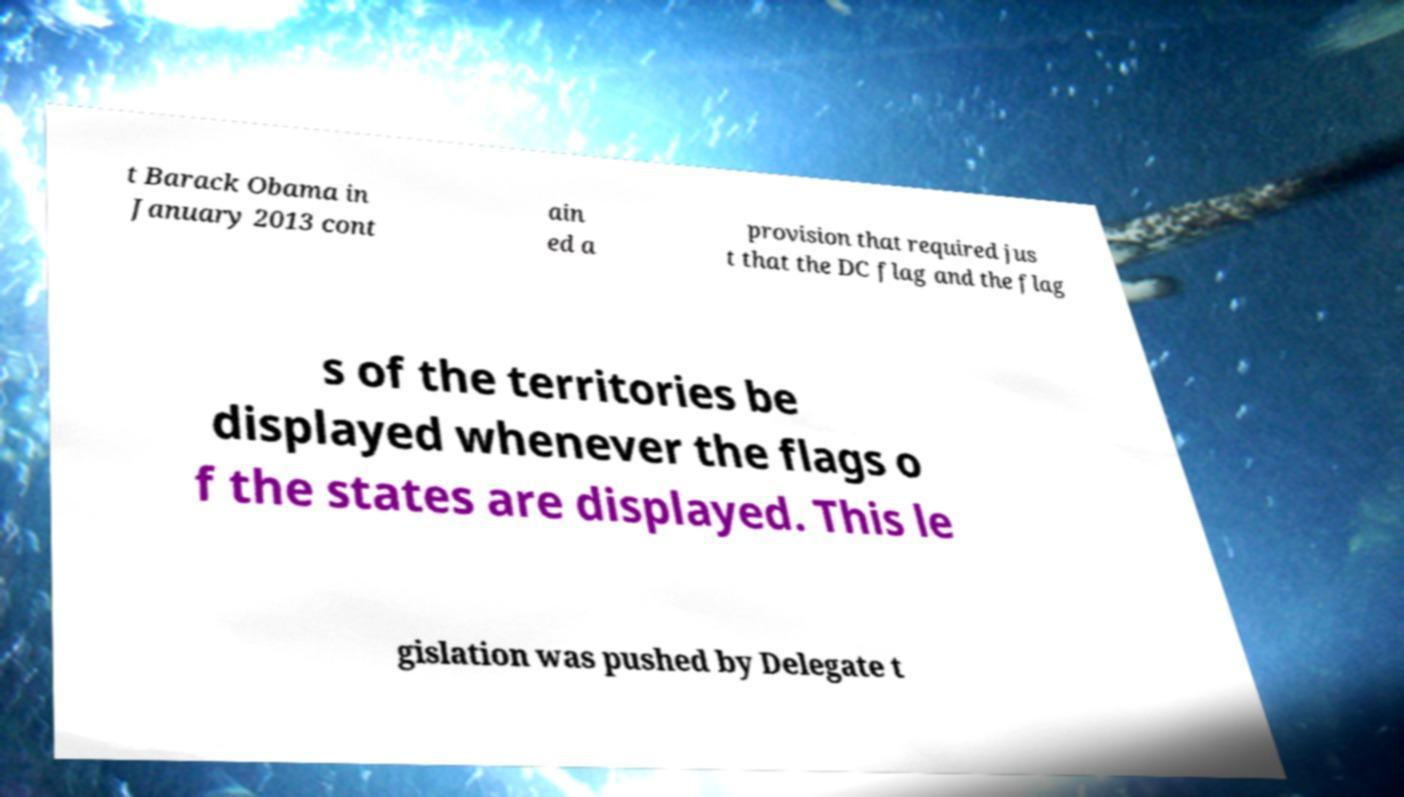Please identify and transcribe the text found in this image. t Barack Obama in January 2013 cont ain ed a provision that required jus t that the DC flag and the flag s of the territories be displayed whenever the flags o f the states are displayed. This le gislation was pushed by Delegate t 